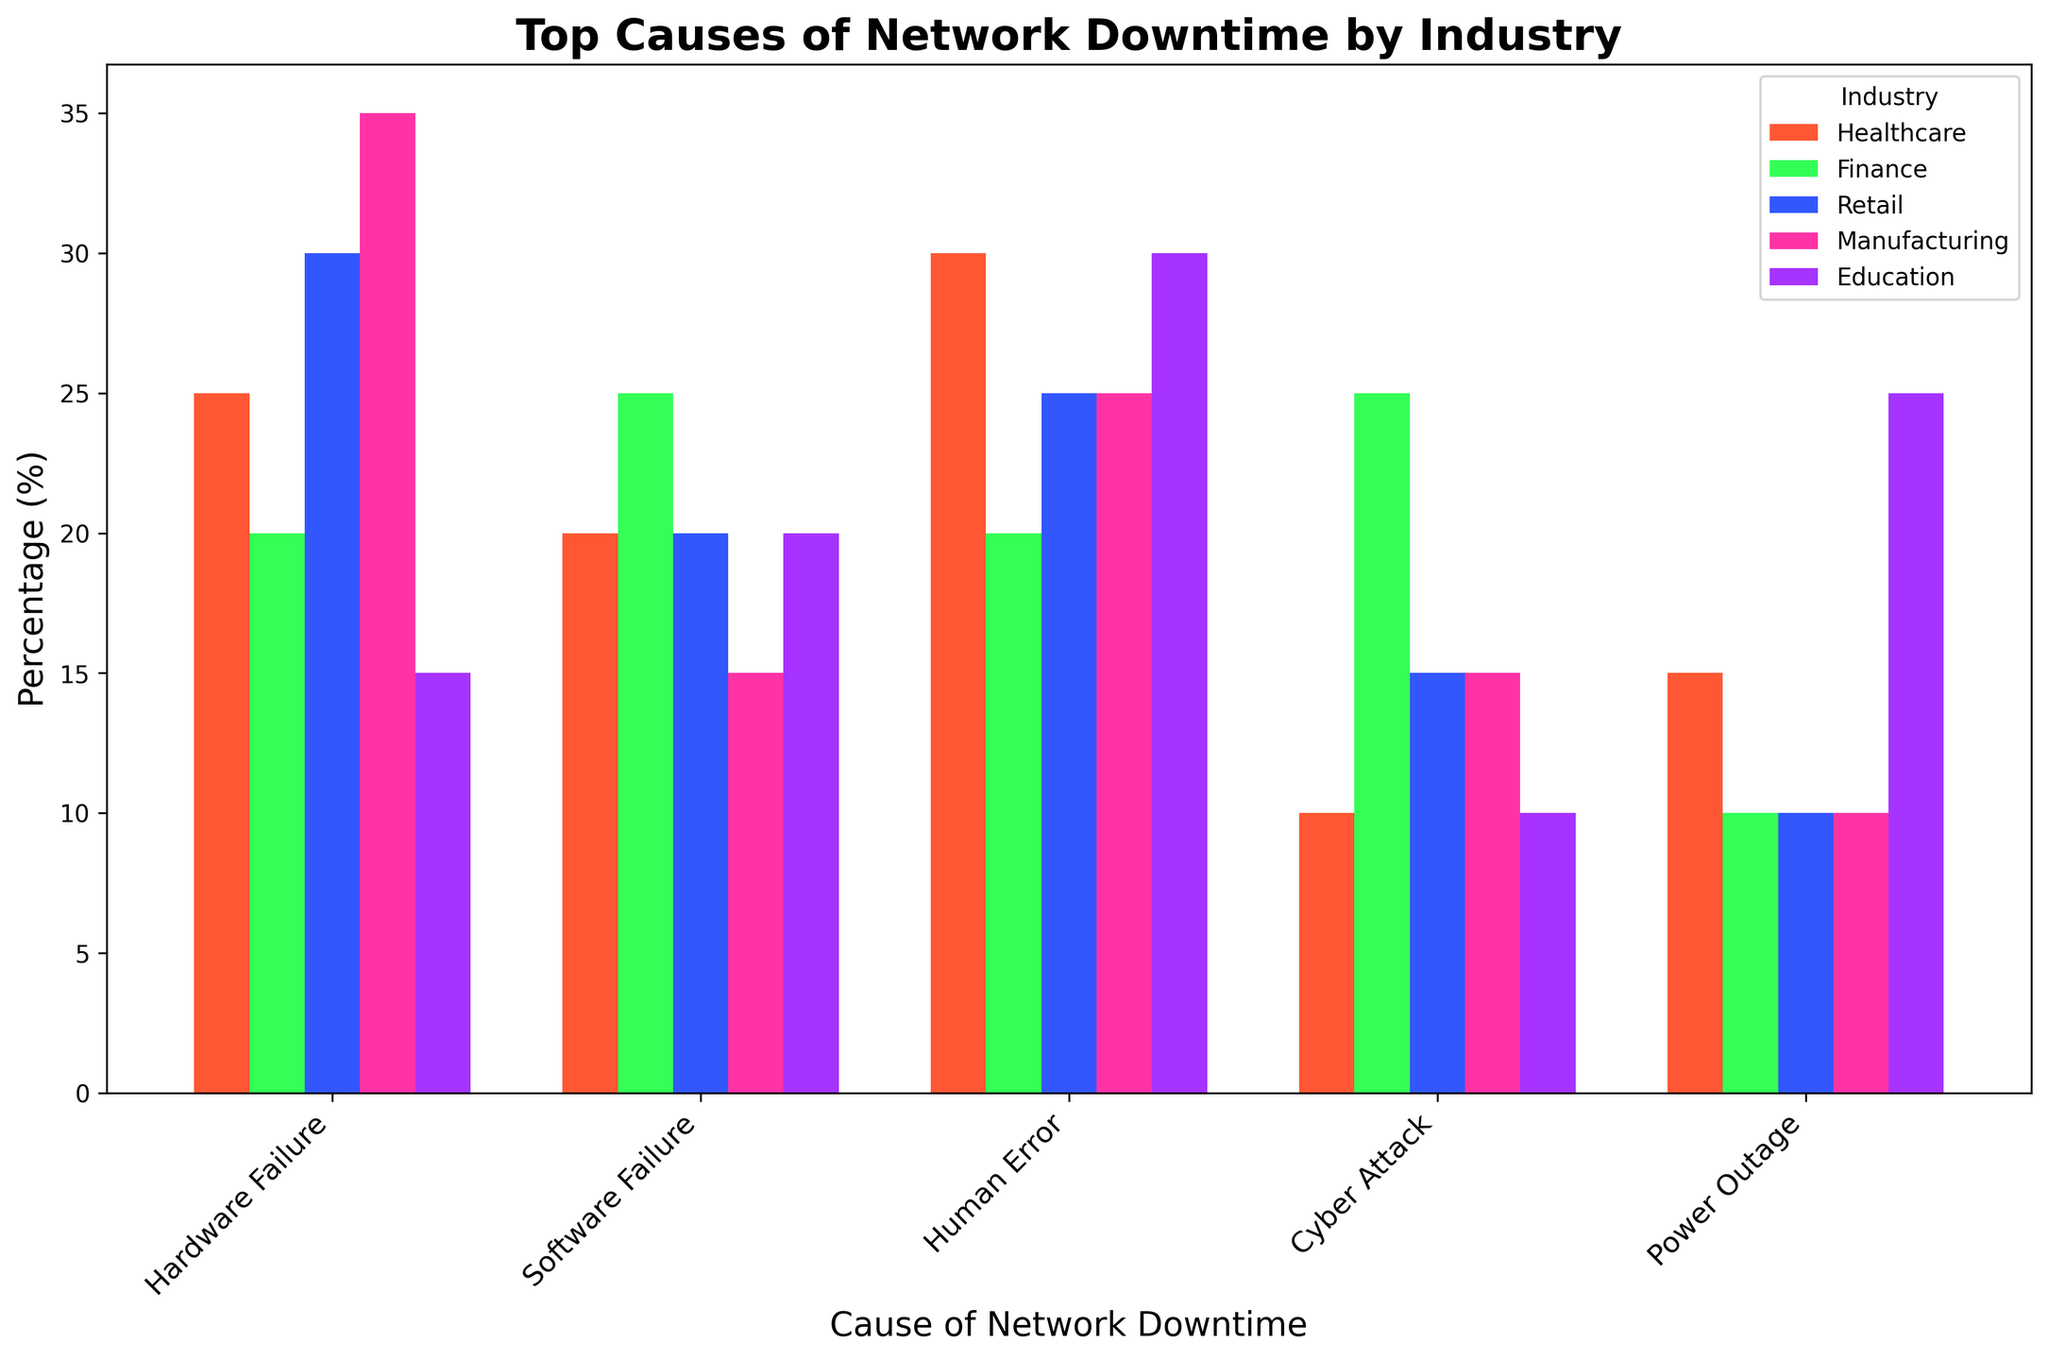Which industry experiences the highest percentage of network downtime due to human error? Healthcare has 30%, Finance has 20%, Retail has 25%, Manufacturing has 25%, and Education has 30%. Therefore, Healthcare and Education both experience the highest percentage of network downtime due to human error.
Answer: Healthcare, Education Which industry has the lowest percentage of network downtime caused by hardware failure? Healthcare has 25%, Finance has 20%, Retail has 30%, Manufacturing has 35%, and Education has 15%. Therefore, Education has the lowest percentage of network downtime caused by hardware failure.
Answer: Education Comparing finance and manufacturing, which industry has a higher percentage of network downtime due to cyber attacks? Finance has 25% downtime due to cyber attacks, while Manufacturing has 15%. Therefore, Finance has a higher percentage of network downtime due to cyber attacks.
Answer: Finance What is the total percentage of network downtime in the retail industry due to hardware and software failures combined? Retail has 30% downtime due to hardware failure and 20% due to software failure. The combined downtime is 30% + 20% = 50%.
Answer: 50% Which cause of network downtime has the highest percentage in the manufacturing industry? Hardware failure in Manufacturing accounts for 35%, software failure 15%, human error 25%, cyber attack 15%, and power outage 10%. Therefore, hardware failure has the highest percentage of network downtime in the manufacturing industry.
Answer: Hardware Failure In healthcare, what is the difference in percentage between network downtime caused by human error and cyber attacks? Healthcare has 30% downtime due to human error and 10% due to cyber attacks. The difference is 30% - 10% = 20%.
Answer: 20% Which industry experiences the highest percentage of network downtime due to power outages? Healthcare has 15%, Finance has 10%, Retail has 10%, Manufacturing has 10%, Education has 25%. Therefore, Education experiences the highest percentage of network downtime due to power outages.
Answer: Education Considering the categories, which cause contributes equally to downtime in both healthcare and retail industries? In Healthcare, software failure contributes 20%. In Retail, software failure also contributes 20%. Therefore, software failure contributes equally to downtime in both industries.
Answer: Software Failure 